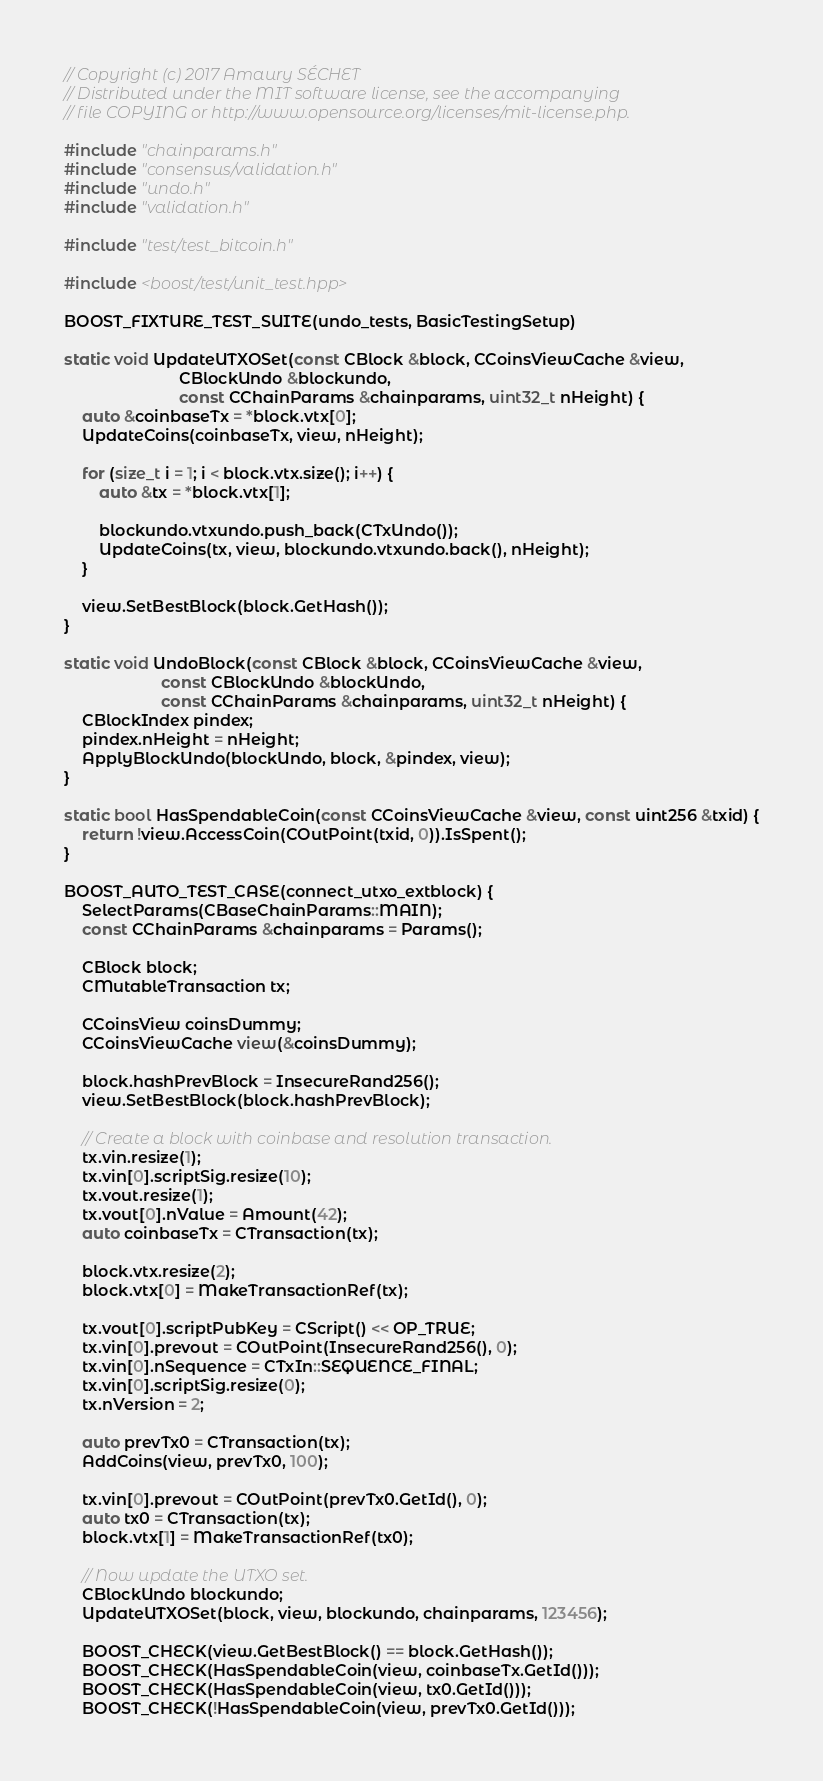<code> <loc_0><loc_0><loc_500><loc_500><_C++_>// Copyright (c) 2017 Amaury SÉCHET
// Distributed under the MIT software license, see the accompanying
// file COPYING or http://www.opensource.org/licenses/mit-license.php.

#include "chainparams.h"
#include "consensus/validation.h"
#include "undo.h"
#include "validation.h"

#include "test/test_bitcoin.h"

#include <boost/test/unit_test.hpp>

BOOST_FIXTURE_TEST_SUITE(undo_tests, BasicTestingSetup)

static void UpdateUTXOSet(const CBlock &block, CCoinsViewCache &view,
                          CBlockUndo &blockundo,
                          const CChainParams &chainparams, uint32_t nHeight) {
    auto &coinbaseTx = *block.vtx[0];
    UpdateCoins(coinbaseTx, view, nHeight);

    for (size_t i = 1; i < block.vtx.size(); i++) {
        auto &tx = *block.vtx[1];

        blockundo.vtxundo.push_back(CTxUndo());
        UpdateCoins(tx, view, blockundo.vtxundo.back(), nHeight);
    }

    view.SetBestBlock(block.GetHash());
}

static void UndoBlock(const CBlock &block, CCoinsViewCache &view,
                      const CBlockUndo &blockUndo,
                      const CChainParams &chainparams, uint32_t nHeight) {
    CBlockIndex pindex;
    pindex.nHeight = nHeight;
    ApplyBlockUndo(blockUndo, block, &pindex, view);
}

static bool HasSpendableCoin(const CCoinsViewCache &view, const uint256 &txid) {
    return !view.AccessCoin(COutPoint(txid, 0)).IsSpent();
}

BOOST_AUTO_TEST_CASE(connect_utxo_extblock) {
    SelectParams(CBaseChainParams::MAIN);
    const CChainParams &chainparams = Params();

    CBlock block;
    CMutableTransaction tx;

    CCoinsView coinsDummy;
    CCoinsViewCache view(&coinsDummy);

    block.hashPrevBlock = InsecureRand256();
    view.SetBestBlock(block.hashPrevBlock);

    // Create a block with coinbase and resolution transaction.
    tx.vin.resize(1);
    tx.vin[0].scriptSig.resize(10);
    tx.vout.resize(1);
    tx.vout[0].nValue = Amount(42);
    auto coinbaseTx = CTransaction(tx);

    block.vtx.resize(2);
    block.vtx[0] = MakeTransactionRef(tx);

    tx.vout[0].scriptPubKey = CScript() << OP_TRUE;
    tx.vin[0].prevout = COutPoint(InsecureRand256(), 0);
    tx.vin[0].nSequence = CTxIn::SEQUENCE_FINAL;
    tx.vin[0].scriptSig.resize(0);
    tx.nVersion = 2;

    auto prevTx0 = CTransaction(tx);
    AddCoins(view, prevTx0, 100);

    tx.vin[0].prevout = COutPoint(prevTx0.GetId(), 0);
    auto tx0 = CTransaction(tx);
    block.vtx[1] = MakeTransactionRef(tx0);

    // Now update the UTXO set.
    CBlockUndo blockundo;
    UpdateUTXOSet(block, view, blockundo, chainparams, 123456);

    BOOST_CHECK(view.GetBestBlock() == block.GetHash());
    BOOST_CHECK(HasSpendableCoin(view, coinbaseTx.GetId()));
    BOOST_CHECK(HasSpendableCoin(view, tx0.GetId()));
    BOOST_CHECK(!HasSpendableCoin(view, prevTx0.GetId()));
</code> 